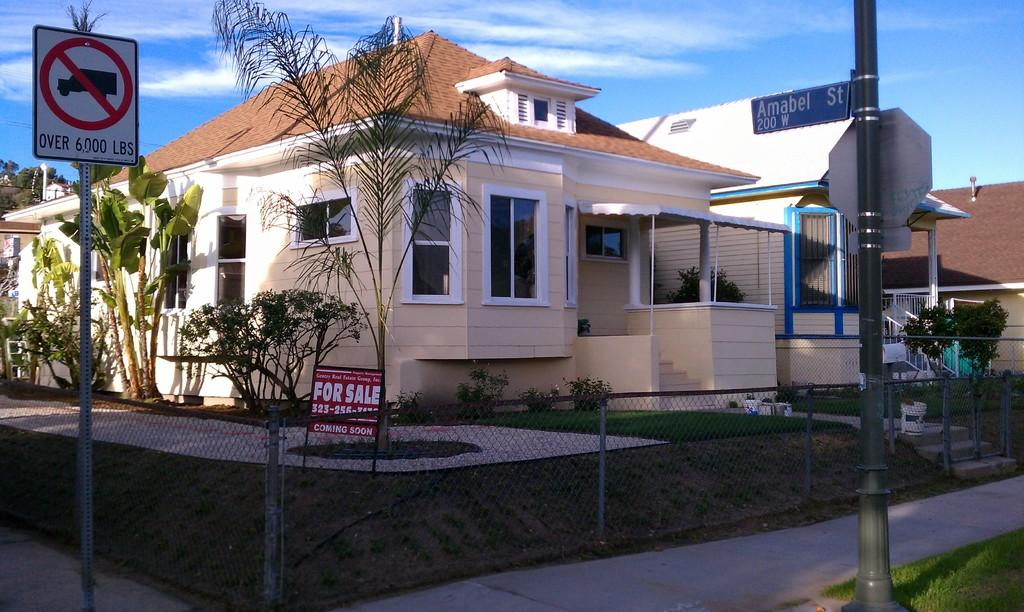<image>
Provide a brief description of the given image. Trucks over 6000 lbs are not allowed on Amabel st. 